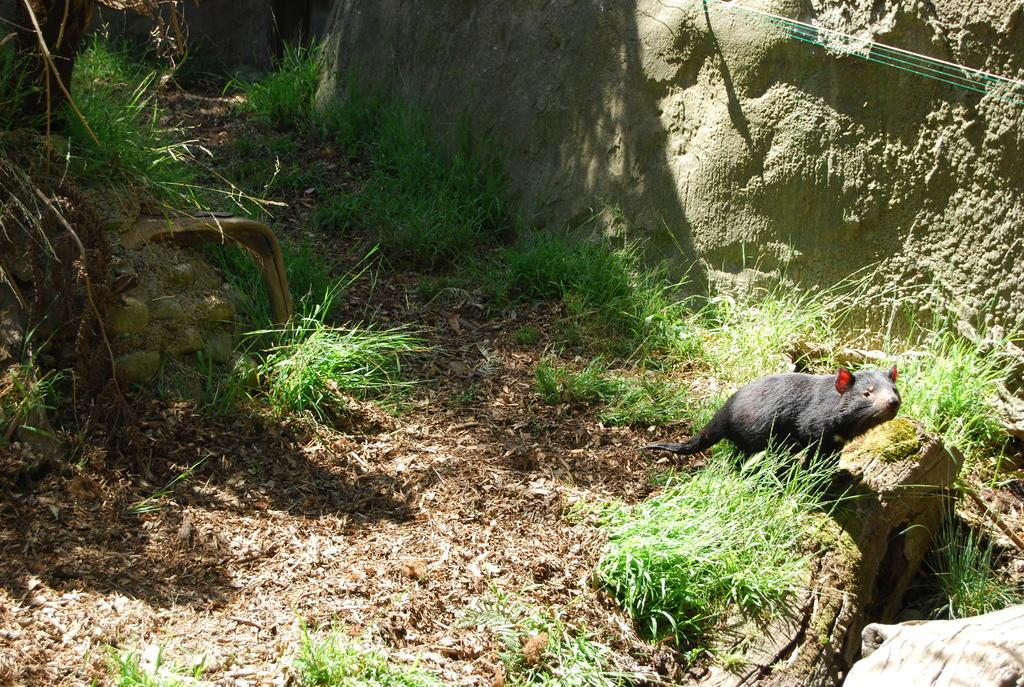What type of vegetation is present in the image? There is grass in the image. What animal can be seen on the right side of the image? There is a rat on the right side of the image. What geographical feature is visible at the top of the image? There is a hill at the top of the image. What type of belief is depicted in the image? There is no depiction of a belief in the image; it features grass, a rat, and a hill. Can you describe the road in the image? There is no road present in the image. 